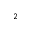<formula> <loc_0><loc_0><loc_500><loc_500>^ { 2 }</formula> 